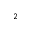<formula> <loc_0><loc_0><loc_500><loc_500>^ { 2 }</formula> 